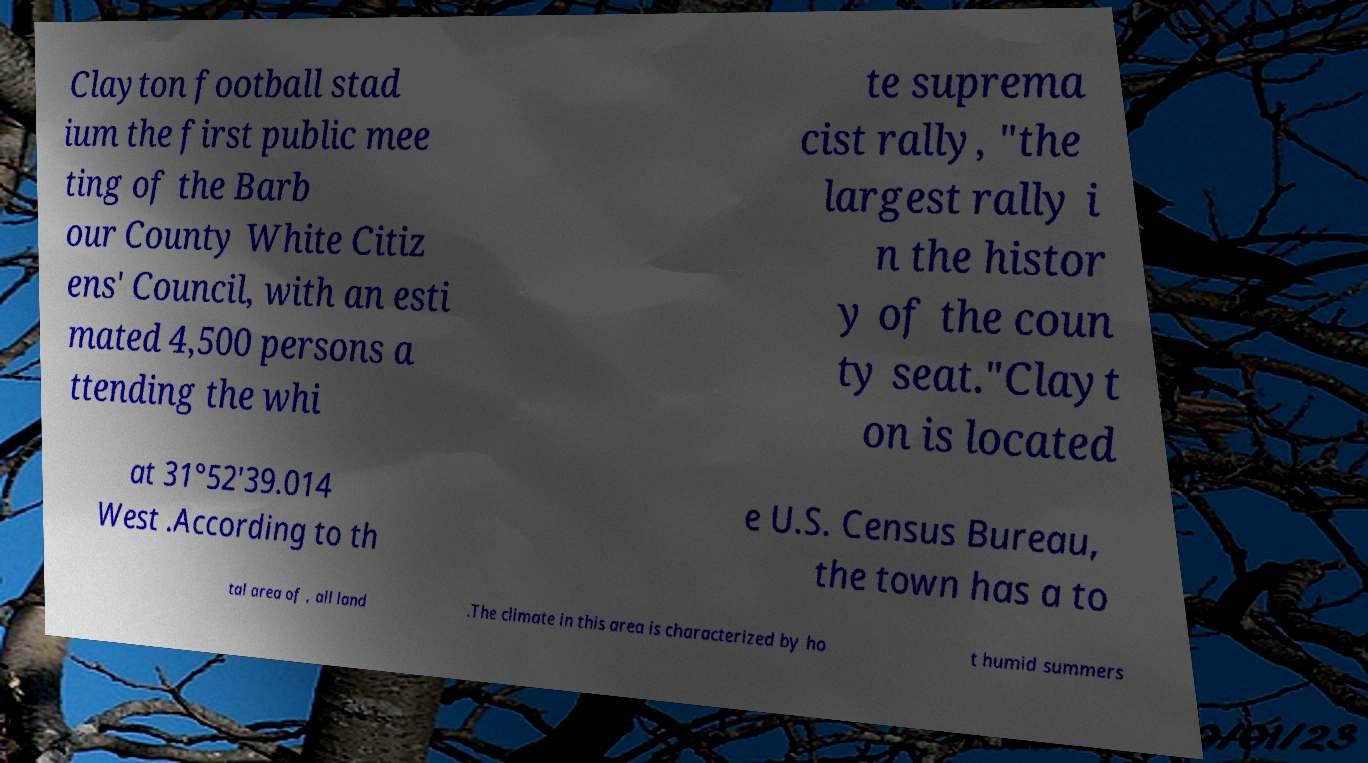Please identify and transcribe the text found in this image. Clayton football stad ium the first public mee ting of the Barb our County White Citiz ens' Council, with an esti mated 4,500 persons a ttending the whi te suprema cist rally, "the largest rally i n the histor y of the coun ty seat."Clayt on is located at 31°52'39.014 West .According to th e U.S. Census Bureau, the town has a to tal area of , all land .The climate in this area is characterized by ho t humid summers 